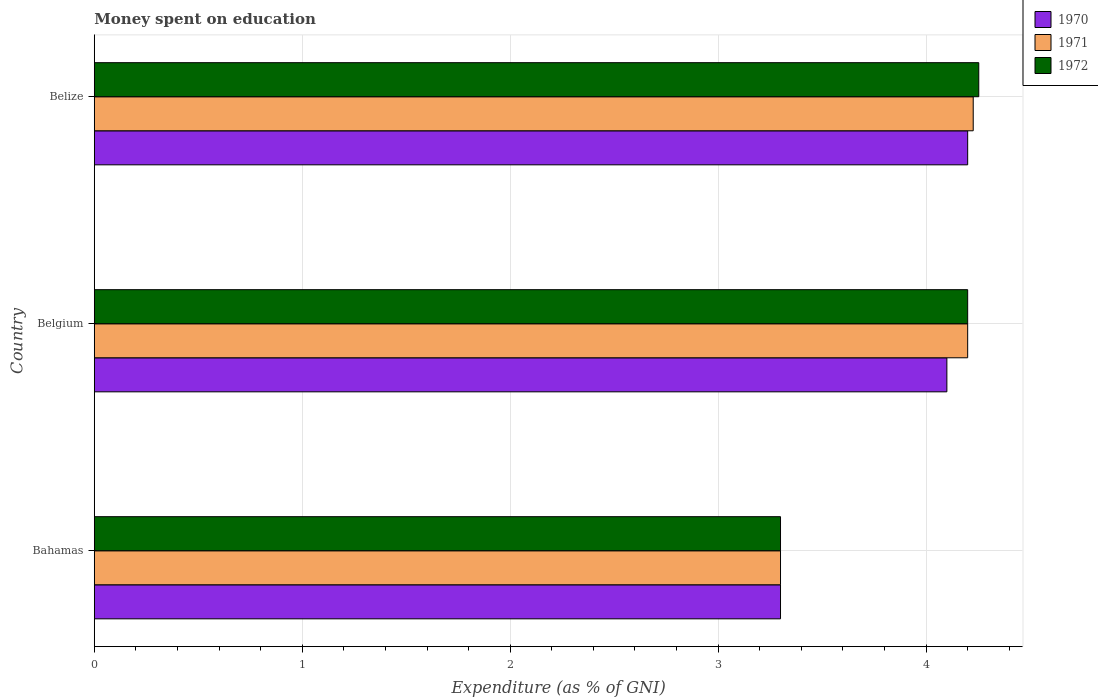How many different coloured bars are there?
Provide a succinct answer. 3. What is the amount of money spent on education in 1972 in Belize?
Your response must be concise. 4.25. Across all countries, what is the maximum amount of money spent on education in 1972?
Provide a succinct answer. 4.25. In which country was the amount of money spent on education in 1972 maximum?
Provide a short and direct response. Belize. In which country was the amount of money spent on education in 1970 minimum?
Give a very brief answer. Bahamas. What is the total amount of money spent on education in 1972 in the graph?
Your answer should be compact. 11.75. What is the difference between the amount of money spent on education in 1970 in Belgium and that in Belize?
Your answer should be very brief. -0.1. What is the difference between the amount of money spent on education in 1972 in Bahamas and the amount of money spent on education in 1971 in Belize?
Your answer should be compact. -0.93. What is the average amount of money spent on education in 1971 per country?
Offer a terse response. 3.91. What is the difference between the amount of money spent on education in 1972 and amount of money spent on education in 1970 in Belize?
Your answer should be very brief. 0.05. What is the ratio of the amount of money spent on education in 1972 in Belgium to that in Belize?
Keep it short and to the point. 0.99. Is the difference between the amount of money spent on education in 1972 in Belgium and Belize greater than the difference between the amount of money spent on education in 1970 in Belgium and Belize?
Offer a very short reply. Yes. What is the difference between the highest and the second highest amount of money spent on education in 1970?
Your response must be concise. 0.1. What is the difference between the highest and the lowest amount of money spent on education in 1971?
Make the answer very short. 0.93. What does the 1st bar from the top in Bahamas represents?
Your answer should be very brief. 1972. What does the 1st bar from the bottom in Belize represents?
Give a very brief answer. 1970. Is it the case that in every country, the sum of the amount of money spent on education in 1971 and amount of money spent on education in 1970 is greater than the amount of money spent on education in 1972?
Ensure brevity in your answer.  Yes. Are all the bars in the graph horizontal?
Provide a short and direct response. Yes. What is the difference between two consecutive major ticks on the X-axis?
Provide a short and direct response. 1. What is the title of the graph?
Your answer should be very brief. Money spent on education. What is the label or title of the X-axis?
Provide a succinct answer. Expenditure (as % of GNI). What is the label or title of the Y-axis?
Your answer should be very brief. Country. What is the Expenditure (as % of GNI) in 1971 in Belgium?
Provide a succinct answer. 4.2. What is the Expenditure (as % of GNI) of 1970 in Belize?
Keep it short and to the point. 4.2. What is the Expenditure (as % of GNI) in 1971 in Belize?
Make the answer very short. 4.23. What is the Expenditure (as % of GNI) in 1972 in Belize?
Your answer should be very brief. 4.25. Across all countries, what is the maximum Expenditure (as % of GNI) of 1971?
Ensure brevity in your answer.  4.23. Across all countries, what is the maximum Expenditure (as % of GNI) of 1972?
Provide a short and direct response. 4.25. Across all countries, what is the minimum Expenditure (as % of GNI) in 1970?
Provide a short and direct response. 3.3. Across all countries, what is the minimum Expenditure (as % of GNI) of 1971?
Provide a short and direct response. 3.3. Across all countries, what is the minimum Expenditure (as % of GNI) of 1972?
Your answer should be compact. 3.3. What is the total Expenditure (as % of GNI) of 1970 in the graph?
Offer a terse response. 11.6. What is the total Expenditure (as % of GNI) of 1971 in the graph?
Offer a terse response. 11.73. What is the total Expenditure (as % of GNI) of 1972 in the graph?
Ensure brevity in your answer.  11.75. What is the difference between the Expenditure (as % of GNI) in 1970 in Bahamas and that in Belgium?
Provide a short and direct response. -0.8. What is the difference between the Expenditure (as % of GNI) in 1971 in Bahamas and that in Belgium?
Keep it short and to the point. -0.9. What is the difference between the Expenditure (as % of GNI) in 1971 in Bahamas and that in Belize?
Provide a short and direct response. -0.93. What is the difference between the Expenditure (as % of GNI) of 1972 in Bahamas and that in Belize?
Ensure brevity in your answer.  -0.95. What is the difference between the Expenditure (as % of GNI) of 1970 in Belgium and that in Belize?
Keep it short and to the point. -0.1. What is the difference between the Expenditure (as % of GNI) in 1971 in Belgium and that in Belize?
Ensure brevity in your answer.  -0.03. What is the difference between the Expenditure (as % of GNI) of 1972 in Belgium and that in Belize?
Provide a succinct answer. -0.05. What is the difference between the Expenditure (as % of GNI) in 1970 in Bahamas and the Expenditure (as % of GNI) in 1971 in Belgium?
Offer a terse response. -0.9. What is the difference between the Expenditure (as % of GNI) of 1970 in Bahamas and the Expenditure (as % of GNI) of 1972 in Belgium?
Offer a very short reply. -0.9. What is the difference between the Expenditure (as % of GNI) of 1970 in Bahamas and the Expenditure (as % of GNI) of 1971 in Belize?
Offer a very short reply. -0.93. What is the difference between the Expenditure (as % of GNI) in 1970 in Bahamas and the Expenditure (as % of GNI) in 1972 in Belize?
Offer a terse response. -0.95. What is the difference between the Expenditure (as % of GNI) in 1971 in Bahamas and the Expenditure (as % of GNI) in 1972 in Belize?
Give a very brief answer. -0.95. What is the difference between the Expenditure (as % of GNI) in 1970 in Belgium and the Expenditure (as % of GNI) in 1971 in Belize?
Provide a succinct answer. -0.13. What is the difference between the Expenditure (as % of GNI) of 1970 in Belgium and the Expenditure (as % of GNI) of 1972 in Belize?
Provide a succinct answer. -0.15. What is the difference between the Expenditure (as % of GNI) of 1971 in Belgium and the Expenditure (as % of GNI) of 1972 in Belize?
Your response must be concise. -0.05. What is the average Expenditure (as % of GNI) in 1970 per country?
Provide a succinct answer. 3.87. What is the average Expenditure (as % of GNI) of 1971 per country?
Keep it short and to the point. 3.91. What is the average Expenditure (as % of GNI) in 1972 per country?
Ensure brevity in your answer.  3.92. What is the difference between the Expenditure (as % of GNI) of 1970 and Expenditure (as % of GNI) of 1971 in Bahamas?
Keep it short and to the point. 0. What is the difference between the Expenditure (as % of GNI) in 1970 and Expenditure (as % of GNI) in 1972 in Bahamas?
Provide a short and direct response. 0. What is the difference between the Expenditure (as % of GNI) in 1971 and Expenditure (as % of GNI) in 1972 in Bahamas?
Offer a terse response. 0. What is the difference between the Expenditure (as % of GNI) of 1970 and Expenditure (as % of GNI) of 1971 in Belgium?
Your response must be concise. -0.1. What is the difference between the Expenditure (as % of GNI) of 1970 and Expenditure (as % of GNI) of 1972 in Belgium?
Your response must be concise. -0.1. What is the difference between the Expenditure (as % of GNI) in 1971 and Expenditure (as % of GNI) in 1972 in Belgium?
Your answer should be compact. 0. What is the difference between the Expenditure (as % of GNI) in 1970 and Expenditure (as % of GNI) in 1971 in Belize?
Ensure brevity in your answer.  -0.03. What is the difference between the Expenditure (as % of GNI) in 1970 and Expenditure (as % of GNI) in 1972 in Belize?
Offer a very short reply. -0.05. What is the difference between the Expenditure (as % of GNI) in 1971 and Expenditure (as % of GNI) in 1972 in Belize?
Your answer should be very brief. -0.03. What is the ratio of the Expenditure (as % of GNI) in 1970 in Bahamas to that in Belgium?
Provide a succinct answer. 0.8. What is the ratio of the Expenditure (as % of GNI) in 1971 in Bahamas to that in Belgium?
Your answer should be compact. 0.79. What is the ratio of the Expenditure (as % of GNI) of 1972 in Bahamas to that in Belgium?
Give a very brief answer. 0.79. What is the ratio of the Expenditure (as % of GNI) in 1970 in Bahamas to that in Belize?
Your response must be concise. 0.79. What is the ratio of the Expenditure (as % of GNI) of 1971 in Bahamas to that in Belize?
Your answer should be compact. 0.78. What is the ratio of the Expenditure (as % of GNI) in 1972 in Bahamas to that in Belize?
Your response must be concise. 0.78. What is the ratio of the Expenditure (as % of GNI) in 1970 in Belgium to that in Belize?
Keep it short and to the point. 0.98. What is the ratio of the Expenditure (as % of GNI) of 1972 in Belgium to that in Belize?
Your response must be concise. 0.99. What is the difference between the highest and the second highest Expenditure (as % of GNI) of 1970?
Your answer should be compact. 0.1. What is the difference between the highest and the second highest Expenditure (as % of GNI) in 1971?
Provide a succinct answer. 0.03. What is the difference between the highest and the second highest Expenditure (as % of GNI) in 1972?
Offer a terse response. 0.05. What is the difference between the highest and the lowest Expenditure (as % of GNI) of 1970?
Ensure brevity in your answer.  0.9. What is the difference between the highest and the lowest Expenditure (as % of GNI) of 1971?
Keep it short and to the point. 0.93. What is the difference between the highest and the lowest Expenditure (as % of GNI) in 1972?
Offer a very short reply. 0.95. 